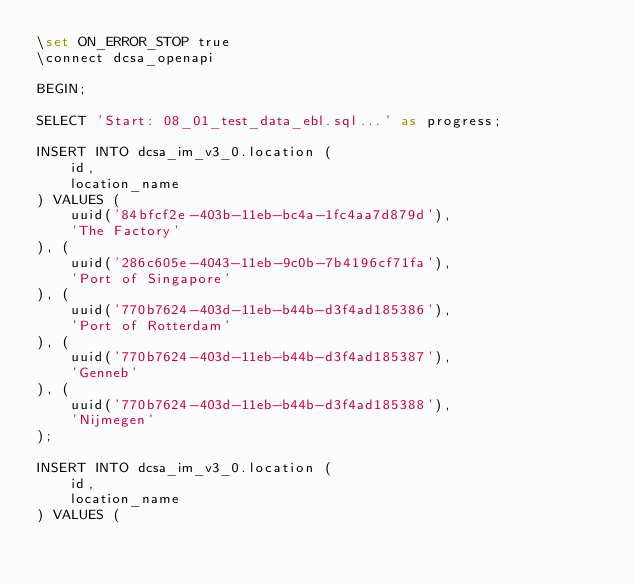Convert code to text. <code><loc_0><loc_0><loc_500><loc_500><_SQL_>\set ON_ERROR_STOP true
\connect dcsa_openapi

BEGIN;

SELECT 'Start: 08_01_test_data_ebl.sql...' as progress;

INSERT INTO dcsa_im_v3_0.location (
    id,
    location_name
) VALUES (
    uuid('84bfcf2e-403b-11eb-bc4a-1fc4aa7d879d'),
    'The Factory'
), (
    uuid('286c605e-4043-11eb-9c0b-7b4196cf71fa'),
    'Port of Singapore'
), (
    uuid('770b7624-403d-11eb-b44b-d3f4ad185386'),
    'Port of Rotterdam'
), (
    uuid('770b7624-403d-11eb-b44b-d3f4ad185387'),
    'Genneb'
), (
    uuid('770b7624-403d-11eb-b44b-d3f4ad185388'),
    'Nijmegen'
);

INSERT INTO dcsa_im_v3_0.location (
    id,
    location_name
) VALUES (</code> 